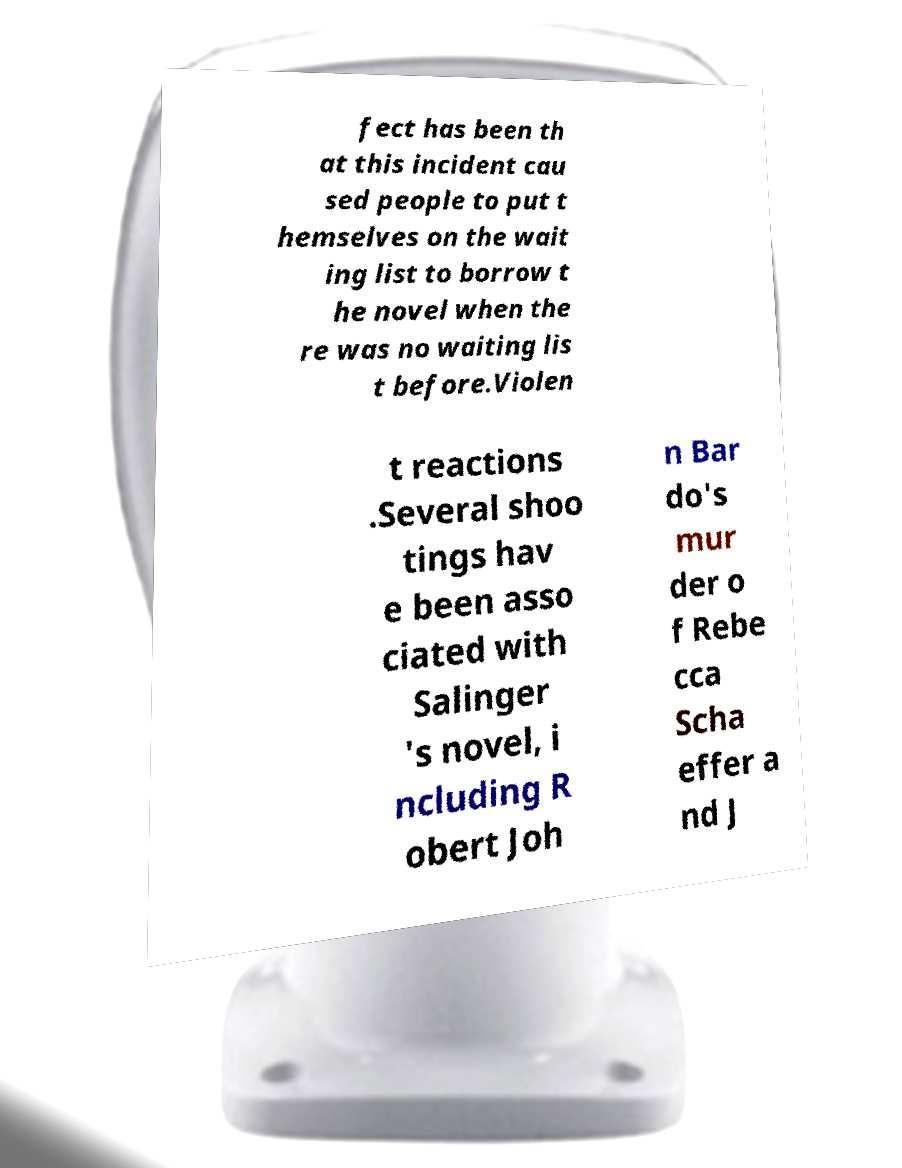Could you assist in decoding the text presented in this image and type it out clearly? fect has been th at this incident cau sed people to put t hemselves on the wait ing list to borrow t he novel when the re was no waiting lis t before.Violen t reactions .Several shoo tings hav e been asso ciated with Salinger 's novel, i ncluding R obert Joh n Bar do's mur der o f Rebe cca Scha effer a nd J 